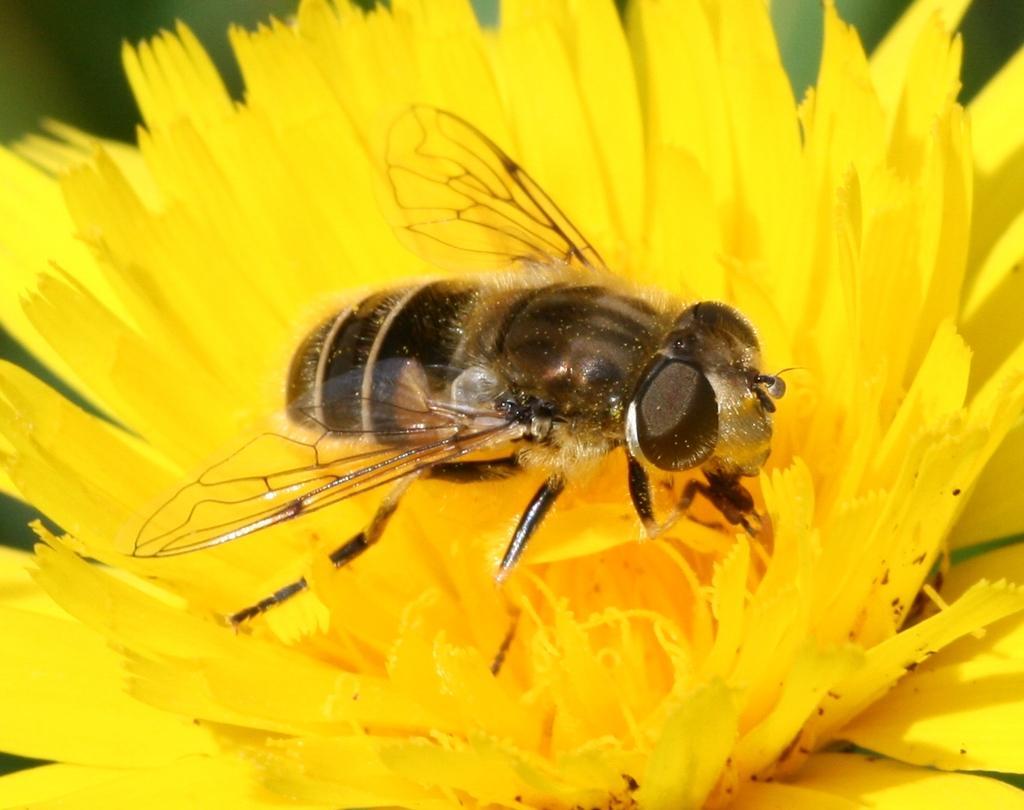How would you summarize this image in a sentence or two? This image consists of a honey bee sitting on a sun flower. The flower is in yellow color. 